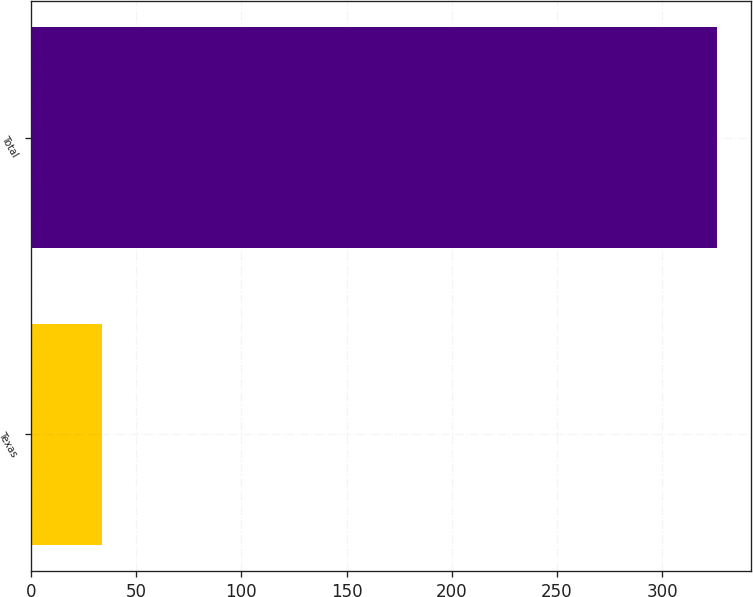Convert chart to OTSL. <chart><loc_0><loc_0><loc_500><loc_500><bar_chart><fcel>Texas<fcel>Total<nl><fcel>34<fcel>326<nl></chart> 